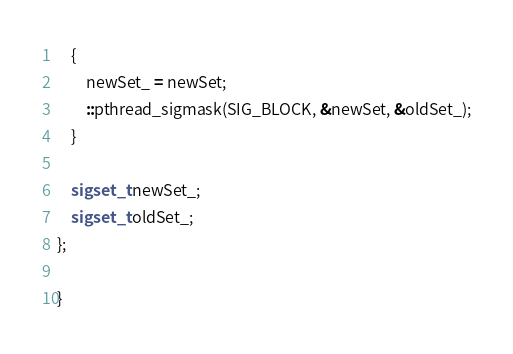<code> <loc_0><loc_0><loc_500><loc_500><_C_>    {
        newSet_ = newSet;
        ::pthread_sigmask(SIG_BLOCK, &newSet, &oldSet_);
    }

    sigset_t newSet_;
    sigset_t oldSet_;
};

}
</code> 